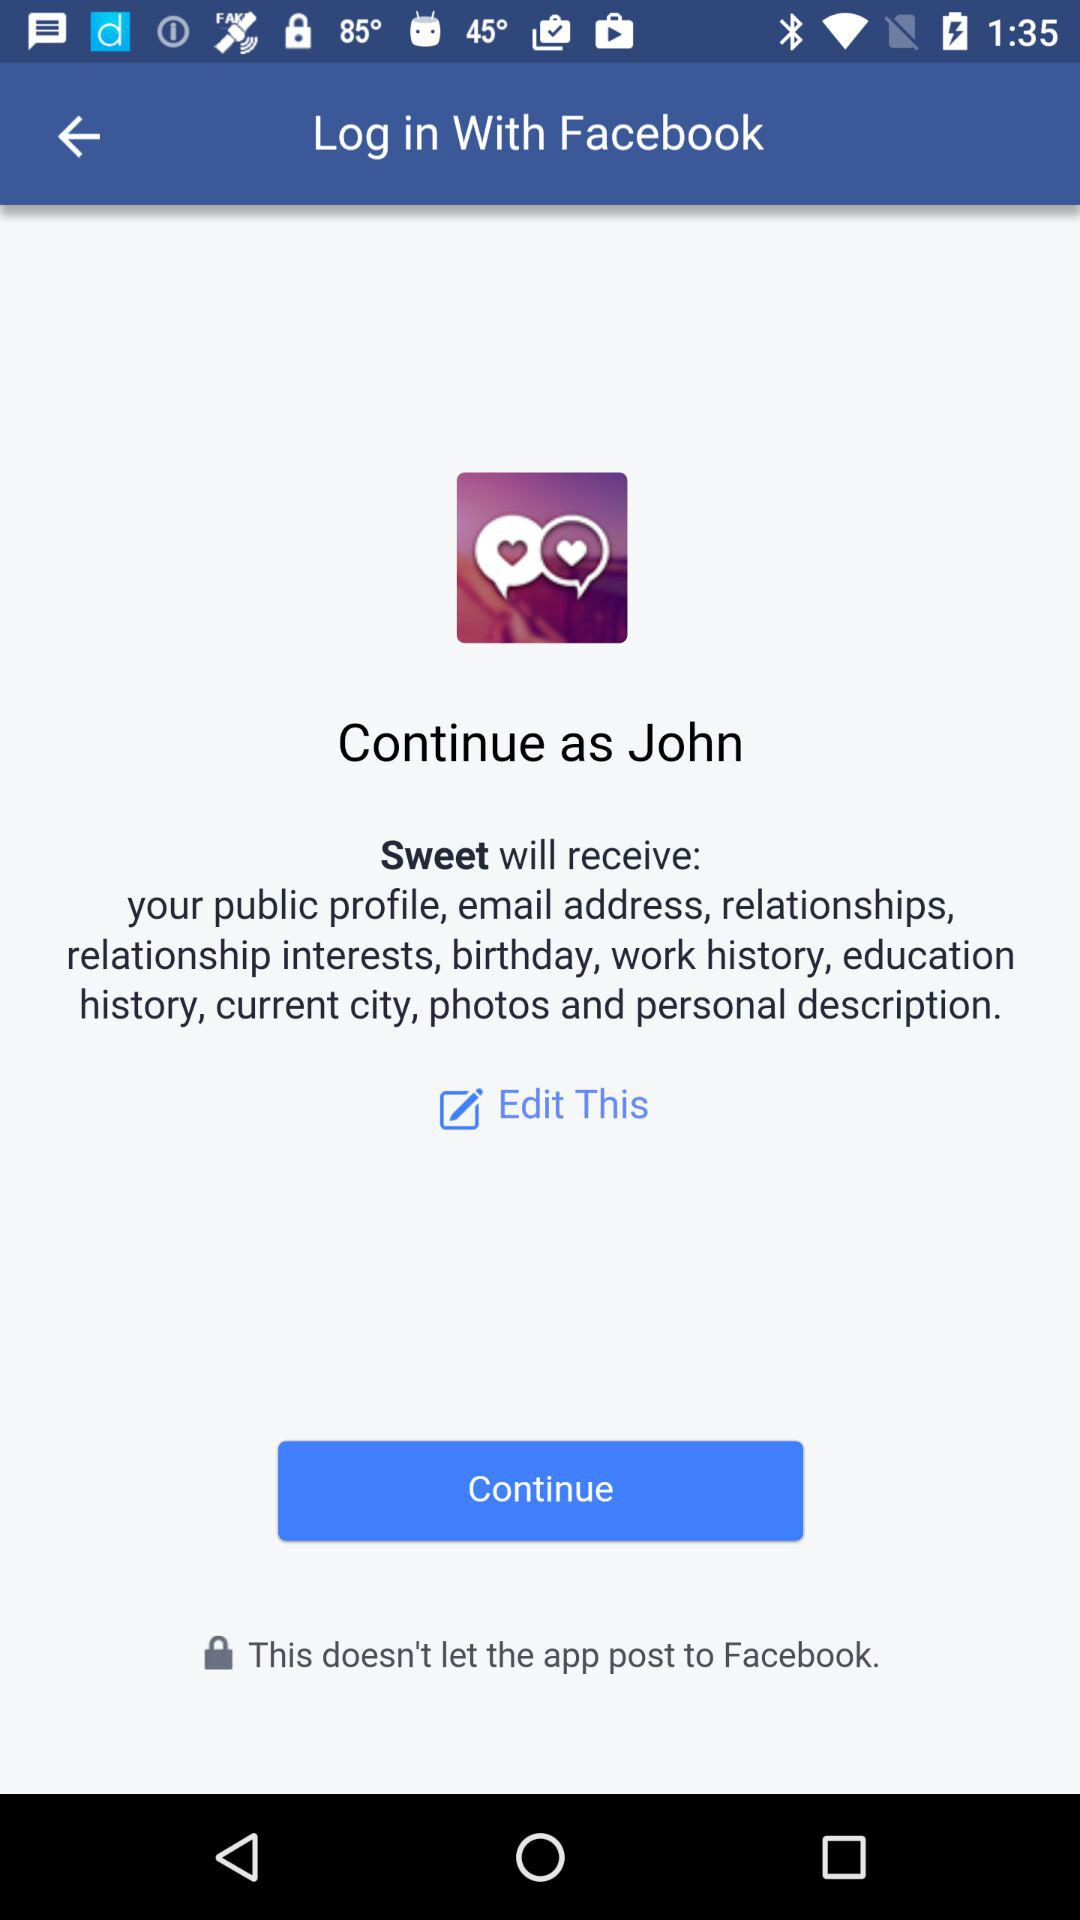Through what account can logging in be done? Logging in can be done through "Facebook". 